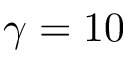Convert formula to latex. <formula><loc_0><loc_0><loc_500><loc_500>\gamma = 1 0</formula> 